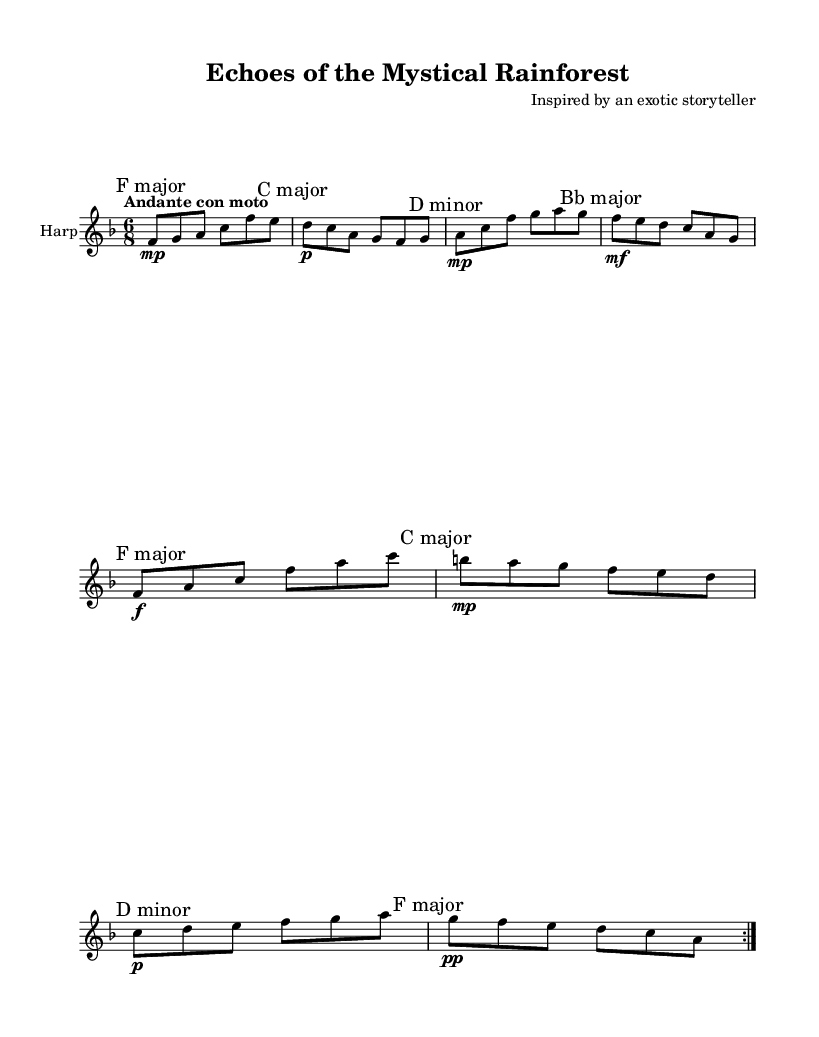What is the key signature of this music? The key signature is F major, indicated by one flat (B flat) in the beginning of the piece.
Answer: F major What is the time signature of this music? The time signature is 6/8, which means there are six eighth notes in each measure.
Answer: 6/8 What is the tempo marking for this sheet music? The tempo marking is "Andante con moto," indicating a moderately slow tempo with movement.
Answer: Andante con moto How many measures are repeated in the score? The score indicates a repeat of the section, marked with "volta 2," which shows that this entire section is played twice.
Answer: 2 What is the dynamic marking for the first measure? The first measure has a dynamic marking of "mp," which stands for "mezzo piano," meaning moderately soft.
Answer: mp What is the last note in the first section of the music? The last note in the first section is "a," which is found at the end of the last measure of the repeated section before the break.
Answer: a How many different key signatures are indicated in the score? The score features four different key signatures indicated by the markings: F major, C major, D minor, and Bb major, highlighting the tonal changes throughout the piece.
Answer: 4 